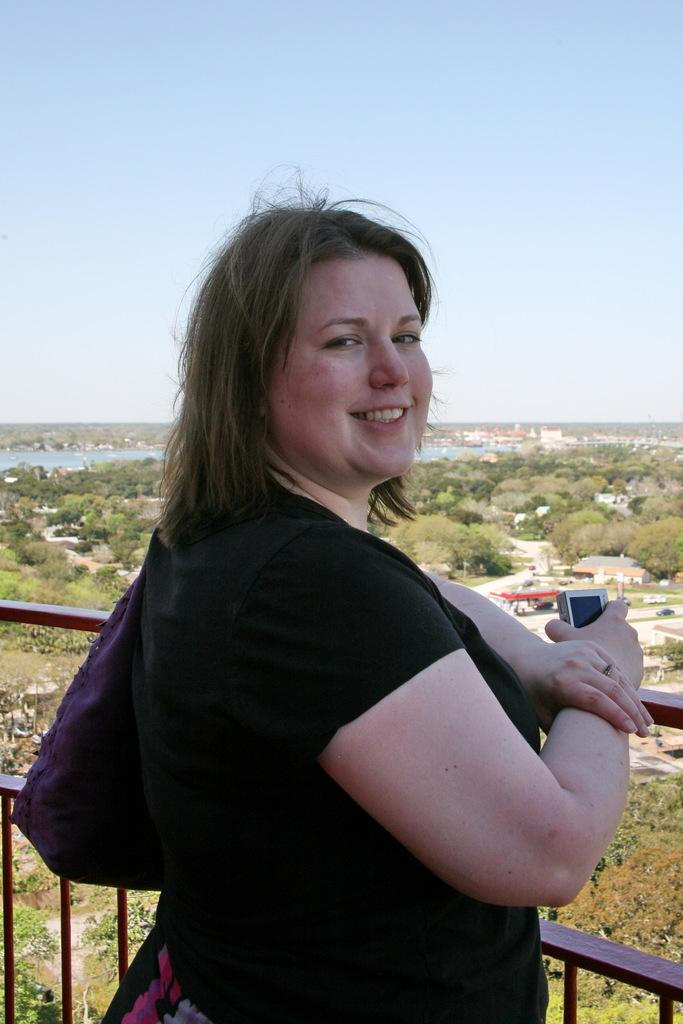What is the lady in the image doing? The lady in the center of the image is standing and smiling. What can be seen at the bottom of the image? Railings are visible at the bottom of the image. What is visible in the background of the image? Trees, buildings, hills, and the sky are visible in the background of the image. Can you describe the water visible in the image? The water is visible in the image, but its exact location or size cannot be determined from the provided facts. Where is the kettle located in the image? There is no kettle present in the image. What type of dog can be seen playing with the lady in the image? There is no dog present in the image; the lady is standing and smiling alone. 